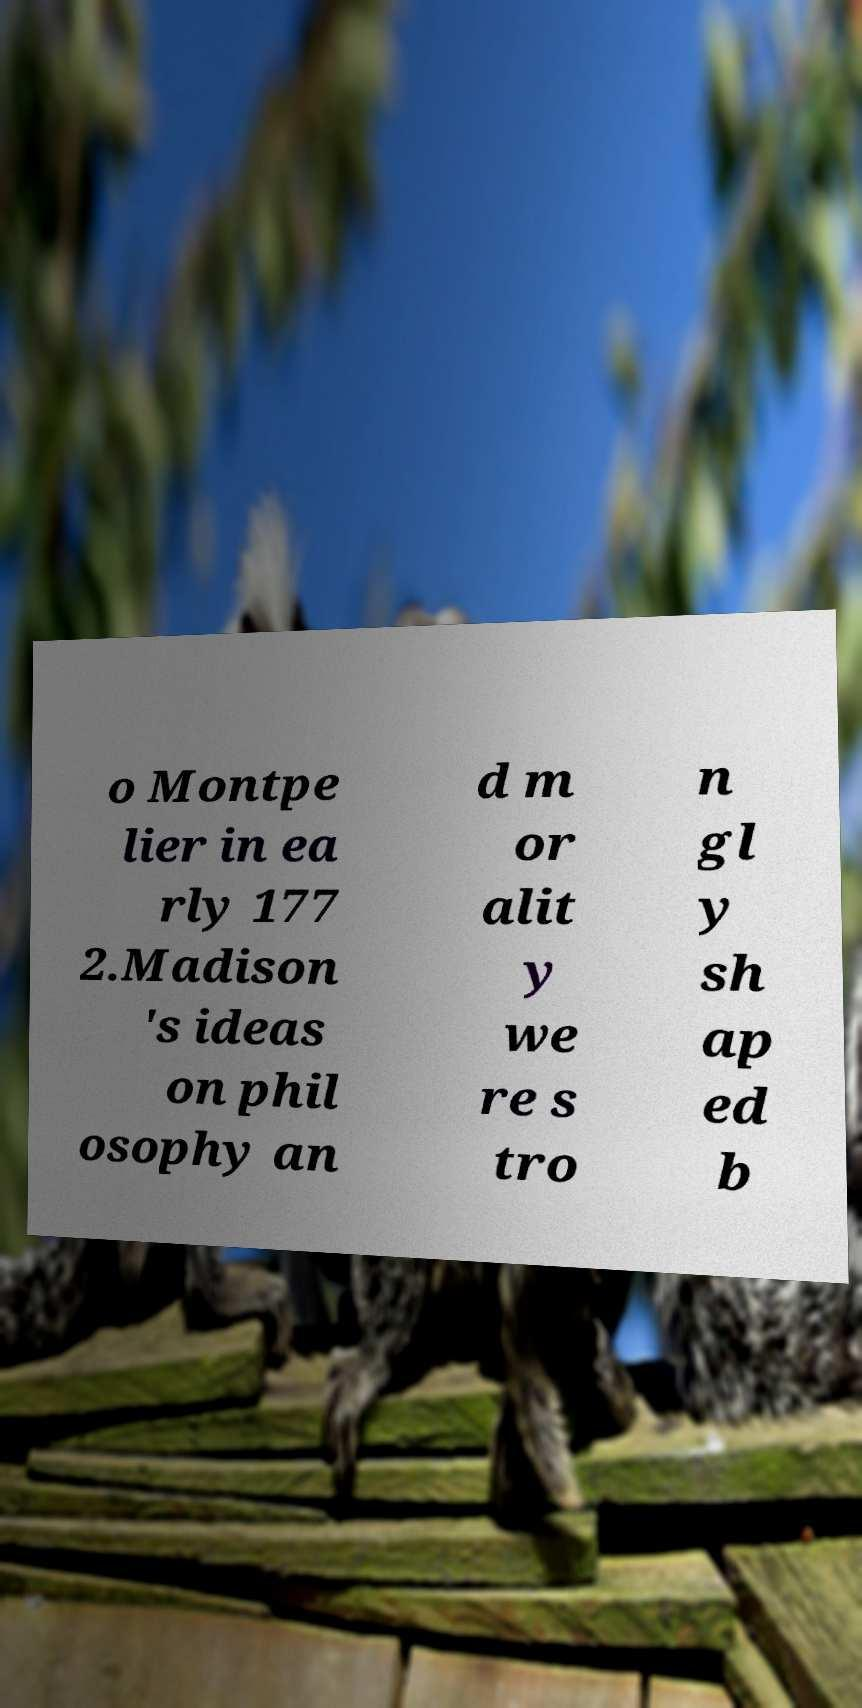Can you accurately transcribe the text from the provided image for me? o Montpe lier in ea rly 177 2.Madison 's ideas on phil osophy an d m or alit y we re s tro n gl y sh ap ed b 